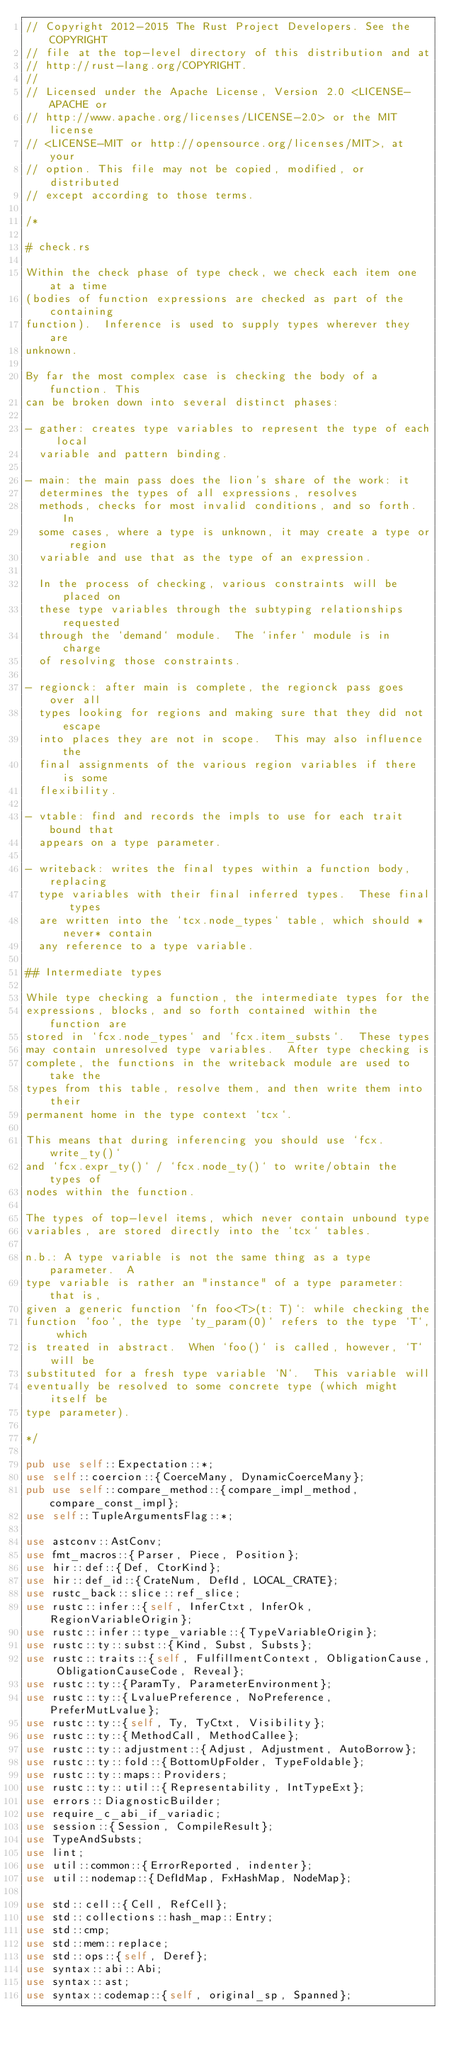<code> <loc_0><loc_0><loc_500><loc_500><_Rust_>// Copyright 2012-2015 The Rust Project Developers. See the COPYRIGHT
// file at the top-level directory of this distribution and at
// http://rust-lang.org/COPYRIGHT.
//
// Licensed under the Apache License, Version 2.0 <LICENSE-APACHE or
// http://www.apache.org/licenses/LICENSE-2.0> or the MIT license
// <LICENSE-MIT or http://opensource.org/licenses/MIT>, at your
// option. This file may not be copied, modified, or distributed
// except according to those terms.

/*

# check.rs

Within the check phase of type check, we check each item one at a time
(bodies of function expressions are checked as part of the containing
function).  Inference is used to supply types wherever they are
unknown.

By far the most complex case is checking the body of a function. This
can be broken down into several distinct phases:

- gather: creates type variables to represent the type of each local
  variable and pattern binding.

- main: the main pass does the lion's share of the work: it
  determines the types of all expressions, resolves
  methods, checks for most invalid conditions, and so forth.  In
  some cases, where a type is unknown, it may create a type or region
  variable and use that as the type of an expression.

  In the process of checking, various constraints will be placed on
  these type variables through the subtyping relationships requested
  through the `demand` module.  The `infer` module is in charge
  of resolving those constraints.

- regionck: after main is complete, the regionck pass goes over all
  types looking for regions and making sure that they did not escape
  into places they are not in scope.  This may also influence the
  final assignments of the various region variables if there is some
  flexibility.

- vtable: find and records the impls to use for each trait bound that
  appears on a type parameter.

- writeback: writes the final types within a function body, replacing
  type variables with their final inferred types.  These final types
  are written into the `tcx.node_types` table, which should *never* contain
  any reference to a type variable.

## Intermediate types

While type checking a function, the intermediate types for the
expressions, blocks, and so forth contained within the function are
stored in `fcx.node_types` and `fcx.item_substs`.  These types
may contain unresolved type variables.  After type checking is
complete, the functions in the writeback module are used to take the
types from this table, resolve them, and then write them into their
permanent home in the type context `tcx`.

This means that during inferencing you should use `fcx.write_ty()`
and `fcx.expr_ty()` / `fcx.node_ty()` to write/obtain the types of
nodes within the function.

The types of top-level items, which never contain unbound type
variables, are stored directly into the `tcx` tables.

n.b.: A type variable is not the same thing as a type parameter.  A
type variable is rather an "instance" of a type parameter: that is,
given a generic function `fn foo<T>(t: T)`: while checking the
function `foo`, the type `ty_param(0)` refers to the type `T`, which
is treated in abstract.  When `foo()` is called, however, `T` will be
substituted for a fresh type variable `N`.  This variable will
eventually be resolved to some concrete type (which might itself be
type parameter).

*/

pub use self::Expectation::*;
use self::coercion::{CoerceMany, DynamicCoerceMany};
pub use self::compare_method::{compare_impl_method, compare_const_impl};
use self::TupleArgumentsFlag::*;

use astconv::AstConv;
use fmt_macros::{Parser, Piece, Position};
use hir::def::{Def, CtorKind};
use hir::def_id::{CrateNum, DefId, LOCAL_CRATE};
use rustc_back::slice::ref_slice;
use rustc::infer::{self, InferCtxt, InferOk, RegionVariableOrigin};
use rustc::infer::type_variable::{TypeVariableOrigin};
use rustc::ty::subst::{Kind, Subst, Substs};
use rustc::traits::{self, FulfillmentContext, ObligationCause, ObligationCauseCode, Reveal};
use rustc::ty::{ParamTy, ParameterEnvironment};
use rustc::ty::{LvaluePreference, NoPreference, PreferMutLvalue};
use rustc::ty::{self, Ty, TyCtxt, Visibility};
use rustc::ty::{MethodCall, MethodCallee};
use rustc::ty::adjustment::{Adjust, Adjustment, AutoBorrow};
use rustc::ty::fold::{BottomUpFolder, TypeFoldable};
use rustc::ty::maps::Providers;
use rustc::ty::util::{Representability, IntTypeExt};
use errors::DiagnosticBuilder;
use require_c_abi_if_variadic;
use session::{Session, CompileResult};
use TypeAndSubsts;
use lint;
use util::common::{ErrorReported, indenter};
use util::nodemap::{DefIdMap, FxHashMap, NodeMap};

use std::cell::{Cell, RefCell};
use std::collections::hash_map::Entry;
use std::cmp;
use std::mem::replace;
use std::ops::{self, Deref};
use syntax::abi::Abi;
use syntax::ast;
use syntax::codemap::{self, original_sp, Spanned};</code> 